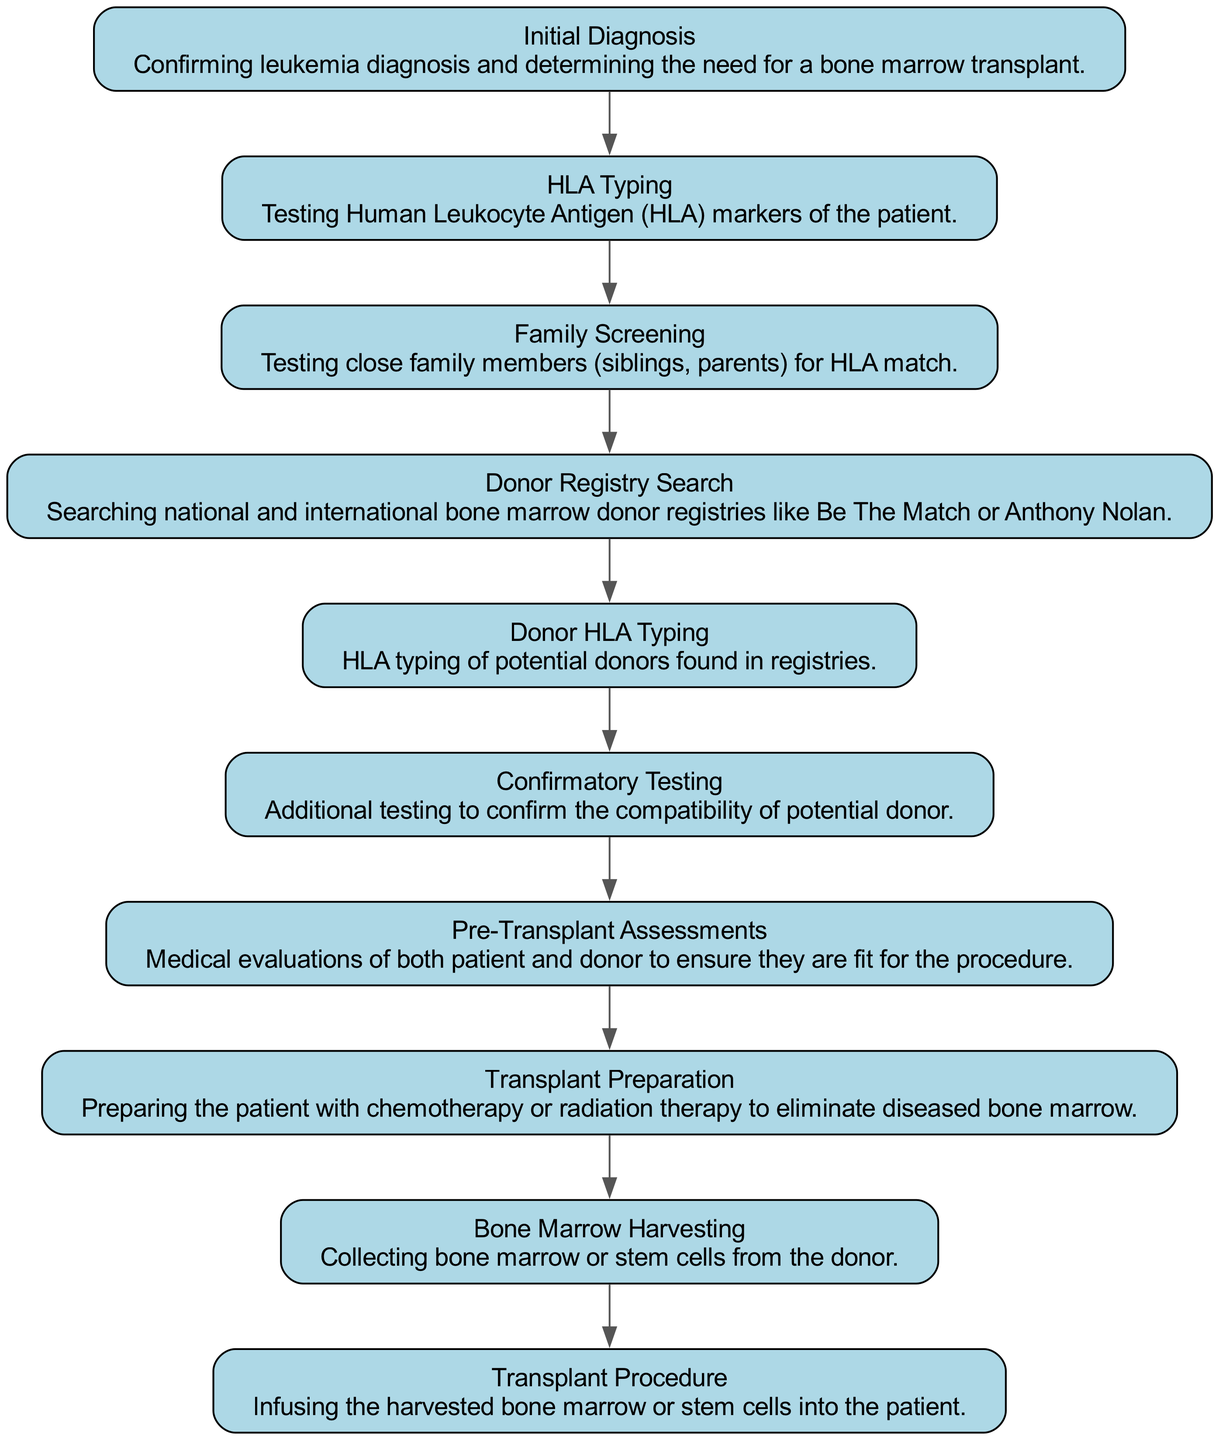What is the first step in the donor matching process? The first step is labeled "Initial Diagnosis," which confirms the leukemia diagnosis and determines the need for a bone marrow transplant.
Answer: Initial Diagnosis How many steps are there in the donor matching process? By counting each labeled step in the diagram, we find that there are a total of ten steps in the donor matching process.
Answer: Ten What follows "Donor Registry Search"? The step that follows "Donor Registry Search" is "Donor HLA Typing," which involves HLA typing of potential donors found in registries.
Answer: Donor HLA Typing What step involves testing close family members for HLA match? This step is called "Family Screening," and it involves testing siblings and parents for HLA compatibility.
Answer: Family Screening What is the purpose of "Confirmatory Testing"? The purpose of "Confirmatory Testing" is to perform additional tests to confirm the compatibility of a potential donor.
Answer: Confirm compatibility What process is initiated after collecting bone marrow or stem cells from the donor? After bone marrow harvesting, the next process is the "Transplant Procedure," where the harvested cells are infused into the patient.
Answer: Transplant Procedure What type of assessments are done prior to the transplant? The assessments conducted are called "Pre-Transplant Assessments," which include medical evaluations of both the patient and donor.
Answer: Pre-Transplant Assessments In which step is the patient prepared to eliminate diseased bone marrow? The step for this preparation is labeled "Transplant Preparation," where the patient undergoes chemotherapy or radiation therapy.
Answer: Transplant Preparation Which step directly involves confirming HLA markers specific to the patient? The step that directly involves this testing is "HLA Typing," where patient's HLA markers are tested.
Answer: HLA Typing 